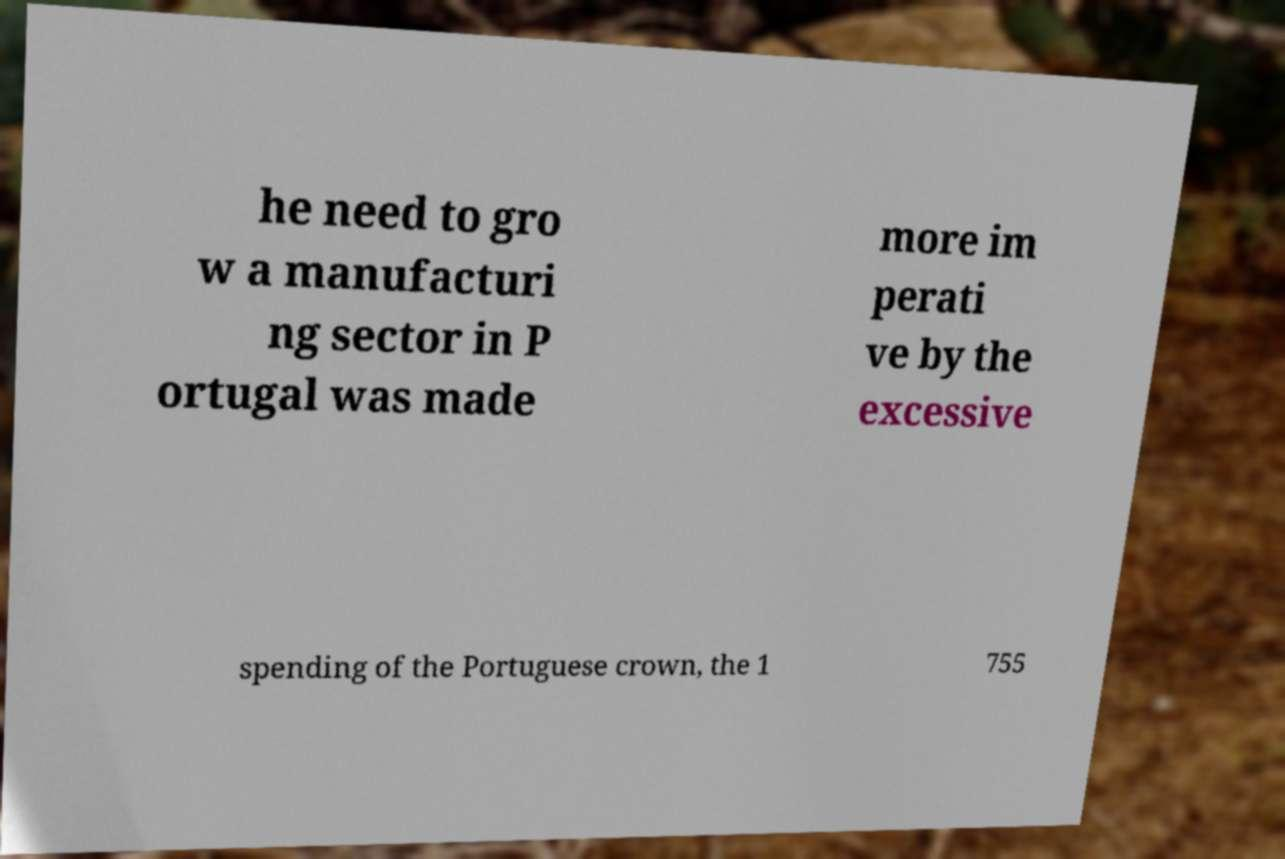Could you extract and type out the text from this image? he need to gro w a manufacturi ng sector in P ortugal was made more im perati ve by the excessive spending of the Portuguese crown, the 1 755 